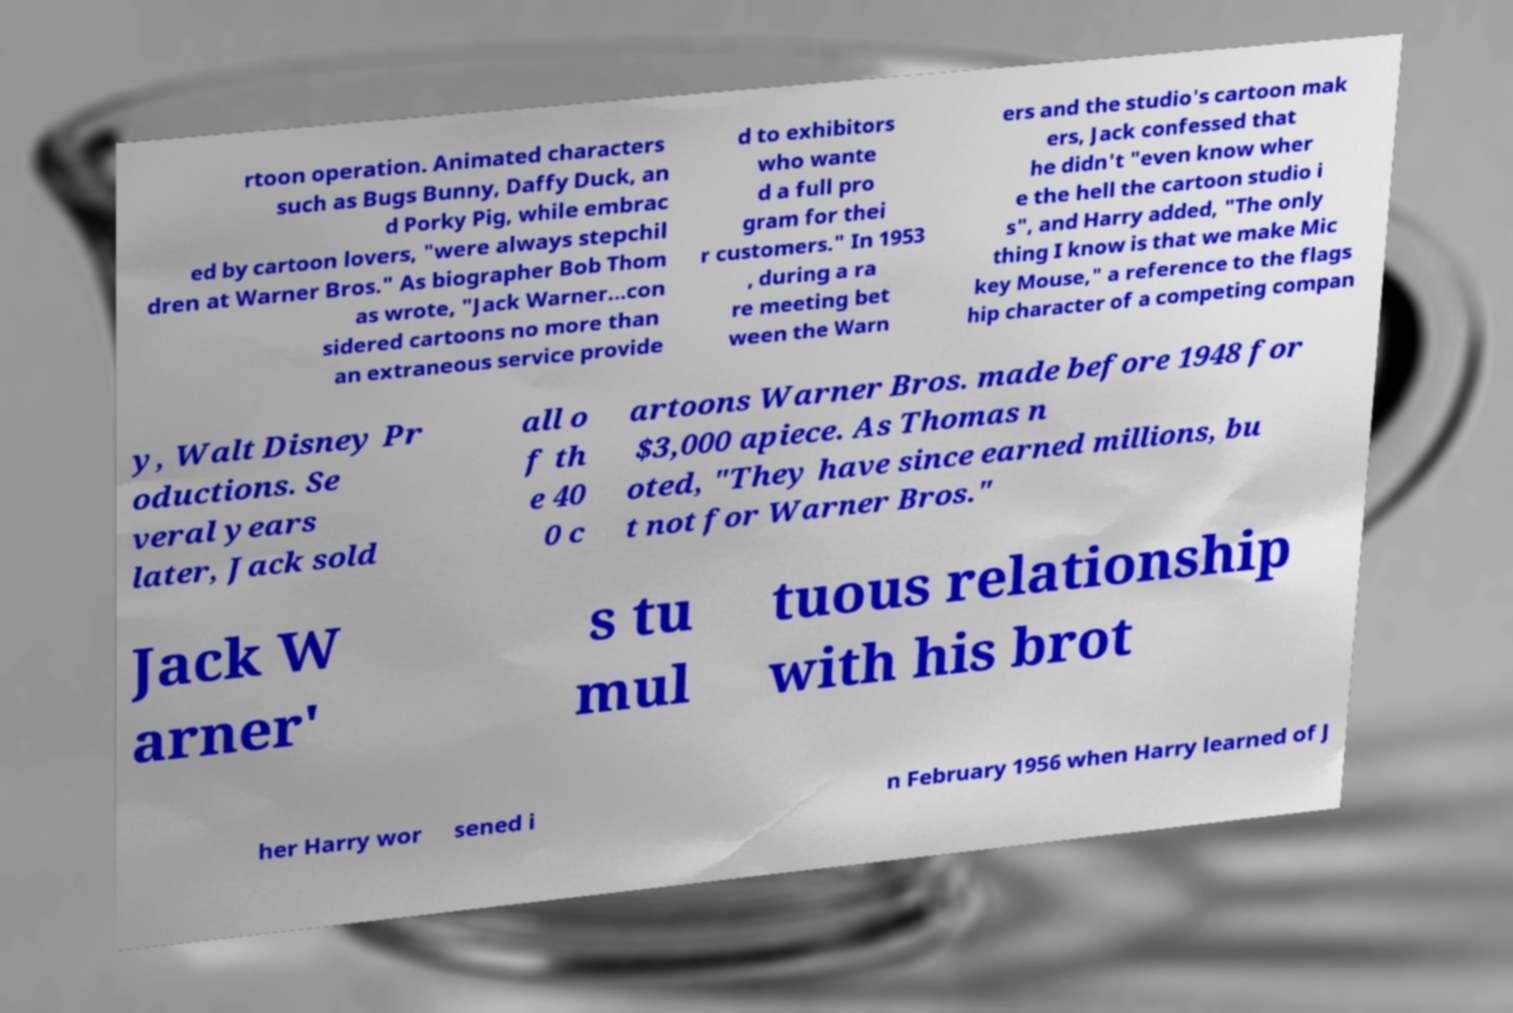There's text embedded in this image that I need extracted. Can you transcribe it verbatim? rtoon operation. Animated characters such as Bugs Bunny, Daffy Duck, an d Porky Pig, while embrac ed by cartoon lovers, "were always stepchil dren at Warner Bros." As biographer Bob Thom as wrote, "Jack Warner...con sidered cartoons no more than an extraneous service provide d to exhibitors who wante d a full pro gram for thei r customers." In 1953 , during a ra re meeting bet ween the Warn ers and the studio's cartoon mak ers, Jack confessed that he didn't "even know wher e the hell the cartoon studio i s", and Harry added, "The only thing I know is that we make Mic key Mouse," a reference to the flags hip character of a competing compan y, Walt Disney Pr oductions. Se veral years later, Jack sold all o f th e 40 0 c artoons Warner Bros. made before 1948 for $3,000 apiece. As Thomas n oted, "They have since earned millions, bu t not for Warner Bros." Jack W arner' s tu mul tuous relationship with his brot her Harry wor sened i n February 1956 when Harry learned of J 